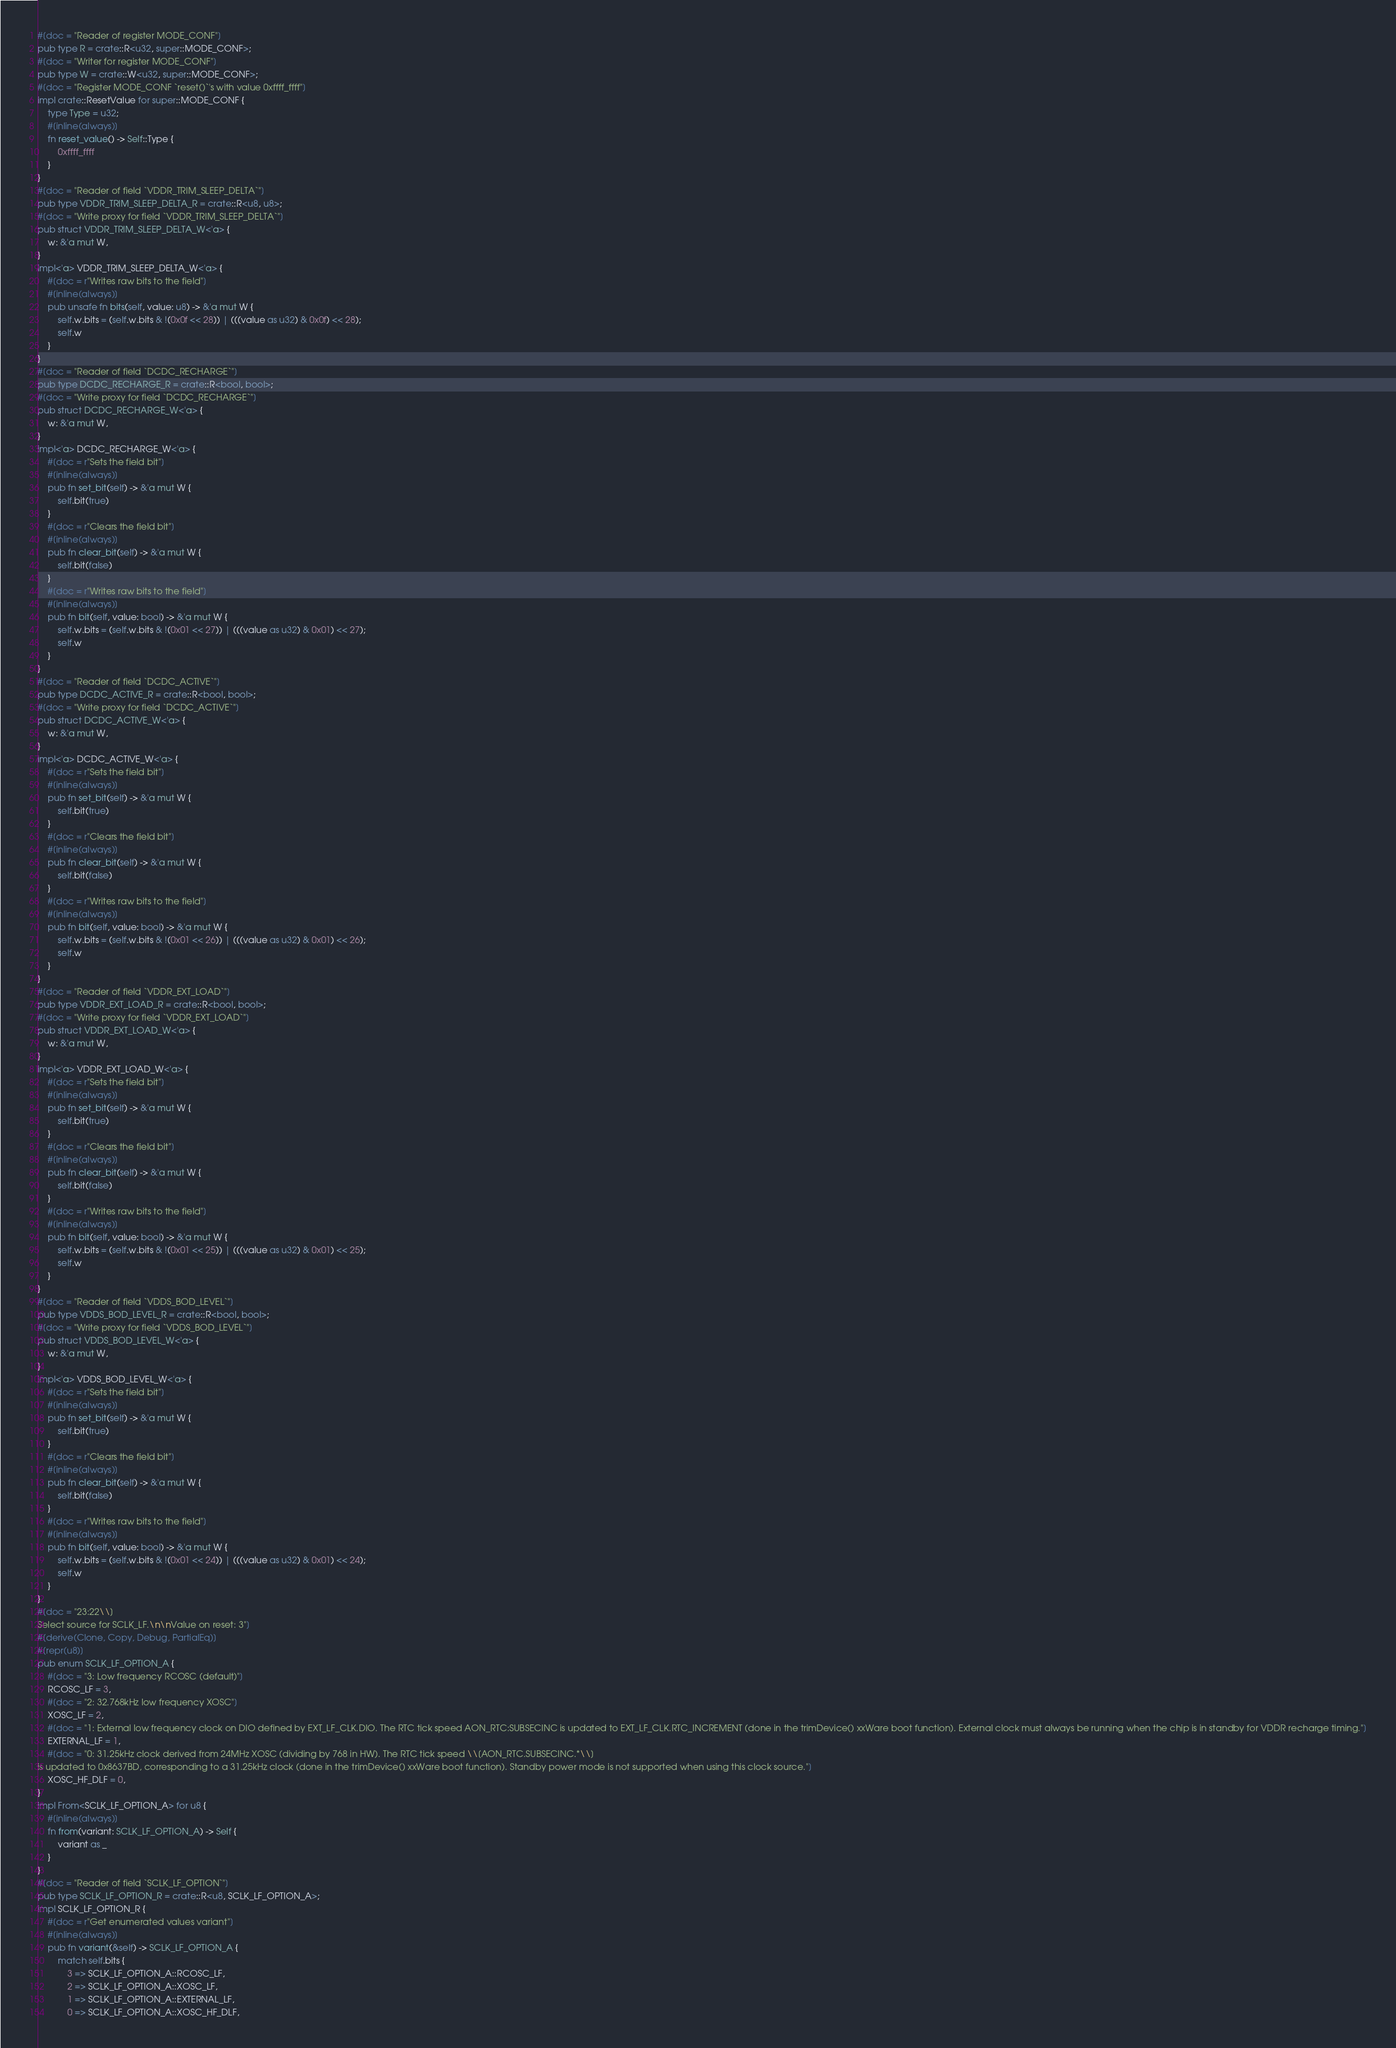Convert code to text. <code><loc_0><loc_0><loc_500><loc_500><_Rust_>#[doc = "Reader of register MODE_CONF"]
pub type R = crate::R<u32, super::MODE_CONF>;
#[doc = "Writer for register MODE_CONF"]
pub type W = crate::W<u32, super::MODE_CONF>;
#[doc = "Register MODE_CONF `reset()`'s with value 0xffff_ffff"]
impl crate::ResetValue for super::MODE_CONF {
    type Type = u32;
    #[inline(always)]
    fn reset_value() -> Self::Type {
        0xffff_ffff
    }
}
#[doc = "Reader of field `VDDR_TRIM_SLEEP_DELTA`"]
pub type VDDR_TRIM_SLEEP_DELTA_R = crate::R<u8, u8>;
#[doc = "Write proxy for field `VDDR_TRIM_SLEEP_DELTA`"]
pub struct VDDR_TRIM_SLEEP_DELTA_W<'a> {
    w: &'a mut W,
}
impl<'a> VDDR_TRIM_SLEEP_DELTA_W<'a> {
    #[doc = r"Writes raw bits to the field"]
    #[inline(always)]
    pub unsafe fn bits(self, value: u8) -> &'a mut W {
        self.w.bits = (self.w.bits & !(0x0f << 28)) | (((value as u32) & 0x0f) << 28);
        self.w
    }
}
#[doc = "Reader of field `DCDC_RECHARGE`"]
pub type DCDC_RECHARGE_R = crate::R<bool, bool>;
#[doc = "Write proxy for field `DCDC_RECHARGE`"]
pub struct DCDC_RECHARGE_W<'a> {
    w: &'a mut W,
}
impl<'a> DCDC_RECHARGE_W<'a> {
    #[doc = r"Sets the field bit"]
    #[inline(always)]
    pub fn set_bit(self) -> &'a mut W {
        self.bit(true)
    }
    #[doc = r"Clears the field bit"]
    #[inline(always)]
    pub fn clear_bit(self) -> &'a mut W {
        self.bit(false)
    }
    #[doc = r"Writes raw bits to the field"]
    #[inline(always)]
    pub fn bit(self, value: bool) -> &'a mut W {
        self.w.bits = (self.w.bits & !(0x01 << 27)) | (((value as u32) & 0x01) << 27);
        self.w
    }
}
#[doc = "Reader of field `DCDC_ACTIVE`"]
pub type DCDC_ACTIVE_R = crate::R<bool, bool>;
#[doc = "Write proxy for field `DCDC_ACTIVE`"]
pub struct DCDC_ACTIVE_W<'a> {
    w: &'a mut W,
}
impl<'a> DCDC_ACTIVE_W<'a> {
    #[doc = r"Sets the field bit"]
    #[inline(always)]
    pub fn set_bit(self) -> &'a mut W {
        self.bit(true)
    }
    #[doc = r"Clears the field bit"]
    #[inline(always)]
    pub fn clear_bit(self) -> &'a mut W {
        self.bit(false)
    }
    #[doc = r"Writes raw bits to the field"]
    #[inline(always)]
    pub fn bit(self, value: bool) -> &'a mut W {
        self.w.bits = (self.w.bits & !(0x01 << 26)) | (((value as u32) & 0x01) << 26);
        self.w
    }
}
#[doc = "Reader of field `VDDR_EXT_LOAD`"]
pub type VDDR_EXT_LOAD_R = crate::R<bool, bool>;
#[doc = "Write proxy for field `VDDR_EXT_LOAD`"]
pub struct VDDR_EXT_LOAD_W<'a> {
    w: &'a mut W,
}
impl<'a> VDDR_EXT_LOAD_W<'a> {
    #[doc = r"Sets the field bit"]
    #[inline(always)]
    pub fn set_bit(self) -> &'a mut W {
        self.bit(true)
    }
    #[doc = r"Clears the field bit"]
    #[inline(always)]
    pub fn clear_bit(self) -> &'a mut W {
        self.bit(false)
    }
    #[doc = r"Writes raw bits to the field"]
    #[inline(always)]
    pub fn bit(self, value: bool) -> &'a mut W {
        self.w.bits = (self.w.bits & !(0x01 << 25)) | (((value as u32) & 0x01) << 25);
        self.w
    }
}
#[doc = "Reader of field `VDDS_BOD_LEVEL`"]
pub type VDDS_BOD_LEVEL_R = crate::R<bool, bool>;
#[doc = "Write proxy for field `VDDS_BOD_LEVEL`"]
pub struct VDDS_BOD_LEVEL_W<'a> {
    w: &'a mut W,
}
impl<'a> VDDS_BOD_LEVEL_W<'a> {
    #[doc = r"Sets the field bit"]
    #[inline(always)]
    pub fn set_bit(self) -> &'a mut W {
        self.bit(true)
    }
    #[doc = r"Clears the field bit"]
    #[inline(always)]
    pub fn clear_bit(self) -> &'a mut W {
        self.bit(false)
    }
    #[doc = r"Writes raw bits to the field"]
    #[inline(always)]
    pub fn bit(self, value: bool) -> &'a mut W {
        self.w.bits = (self.w.bits & !(0x01 << 24)) | (((value as u32) & 0x01) << 24);
        self.w
    }
}
#[doc = "23:22\\]
Select source for SCLK_LF.\n\nValue on reset: 3"]
#[derive(Clone, Copy, Debug, PartialEq)]
#[repr(u8)]
pub enum SCLK_LF_OPTION_A {
    #[doc = "3: Low frequency RCOSC (default)"]
    RCOSC_LF = 3,
    #[doc = "2: 32.768kHz low frequency XOSC"]
    XOSC_LF = 2,
    #[doc = "1: External low frequency clock on DIO defined by EXT_LF_CLK.DIO. The RTC tick speed AON_RTC:SUBSECINC is updated to EXT_LF_CLK.RTC_INCREMENT (done in the trimDevice() xxWare boot function). External clock must always be running when the chip is in standby for VDDR recharge timing."]
    EXTERNAL_LF = 1,
    #[doc = "0: 31.25kHz clock derived from 24MHz XOSC (dividing by 768 in HW). The RTC tick speed \\[AON_RTC.SUBSECINC.*\\]
is updated to 0x8637BD, corresponding to a 31.25kHz clock (done in the trimDevice() xxWare boot function). Standby power mode is not supported when using this clock source."]
    XOSC_HF_DLF = 0,
}
impl From<SCLK_LF_OPTION_A> for u8 {
    #[inline(always)]
    fn from(variant: SCLK_LF_OPTION_A) -> Self {
        variant as _
    }
}
#[doc = "Reader of field `SCLK_LF_OPTION`"]
pub type SCLK_LF_OPTION_R = crate::R<u8, SCLK_LF_OPTION_A>;
impl SCLK_LF_OPTION_R {
    #[doc = r"Get enumerated values variant"]
    #[inline(always)]
    pub fn variant(&self) -> SCLK_LF_OPTION_A {
        match self.bits {
            3 => SCLK_LF_OPTION_A::RCOSC_LF,
            2 => SCLK_LF_OPTION_A::XOSC_LF,
            1 => SCLK_LF_OPTION_A::EXTERNAL_LF,
            0 => SCLK_LF_OPTION_A::XOSC_HF_DLF,</code> 